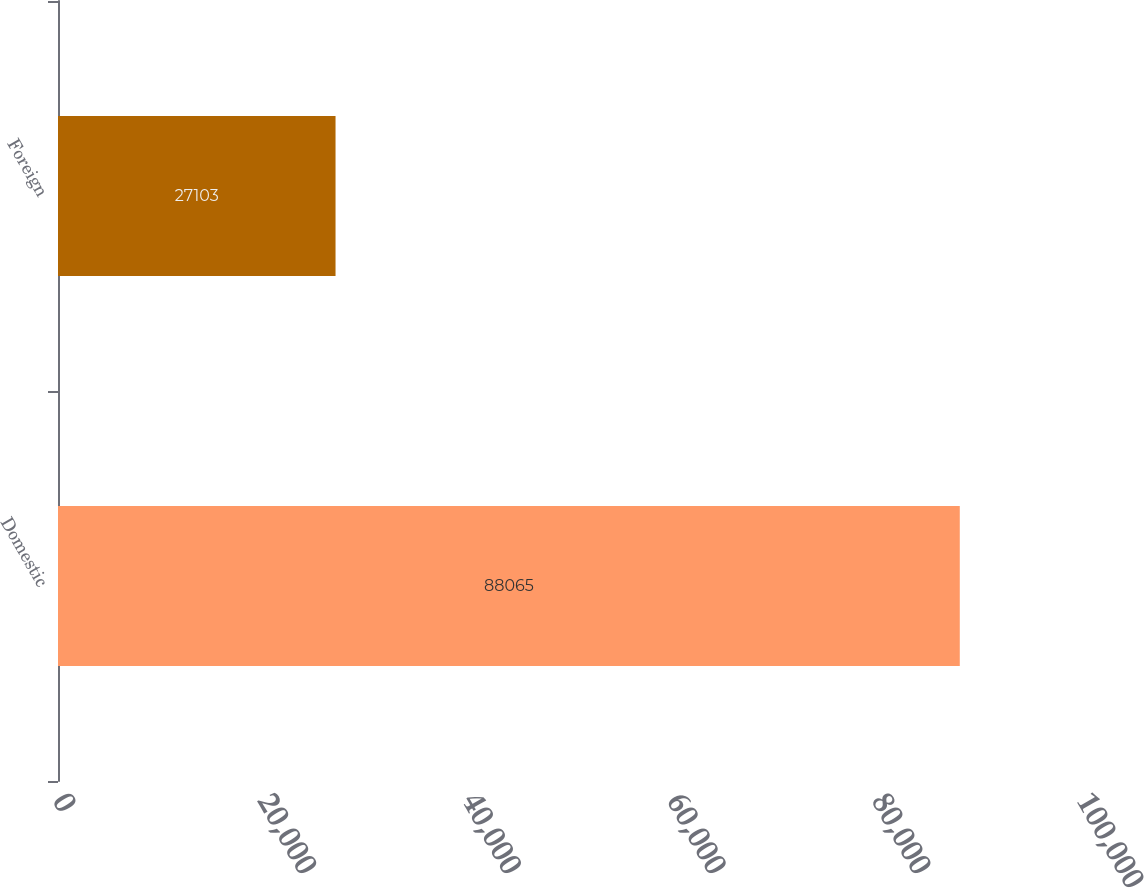Convert chart to OTSL. <chart><loc_0><loc_0><loc_500><loc_500><bar_chart><fcel>Domestic<fcel>Foreign<nl><fcel>88065<fcel>27103<nl></chart> 